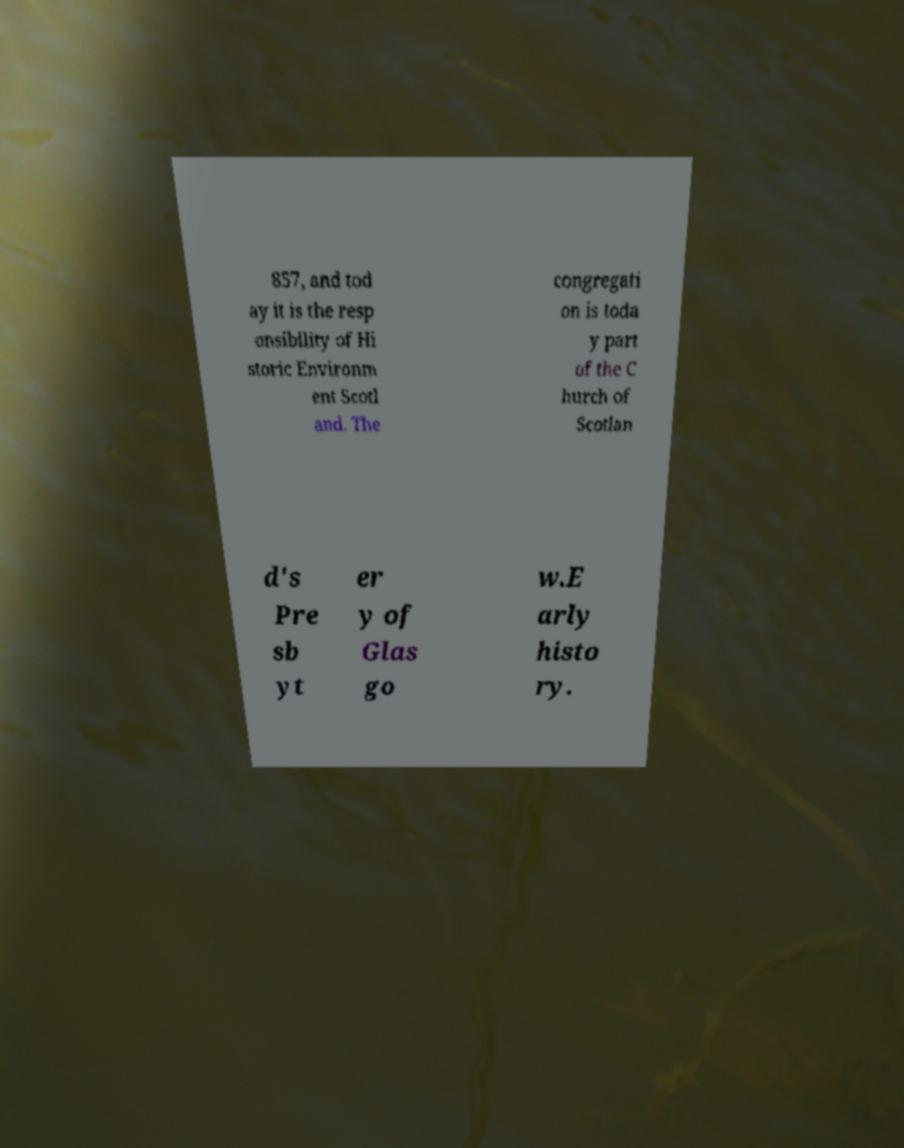Can you accurately transcribe the text from the provided image for me? 857, and tod ay it is the resp onsibility of Hi storic Environm ent Scotl and. The congregati on is toda y part of the C hurch of Scotlan d's Pre sb yt er y of Glas go w.E arly histo ry. 